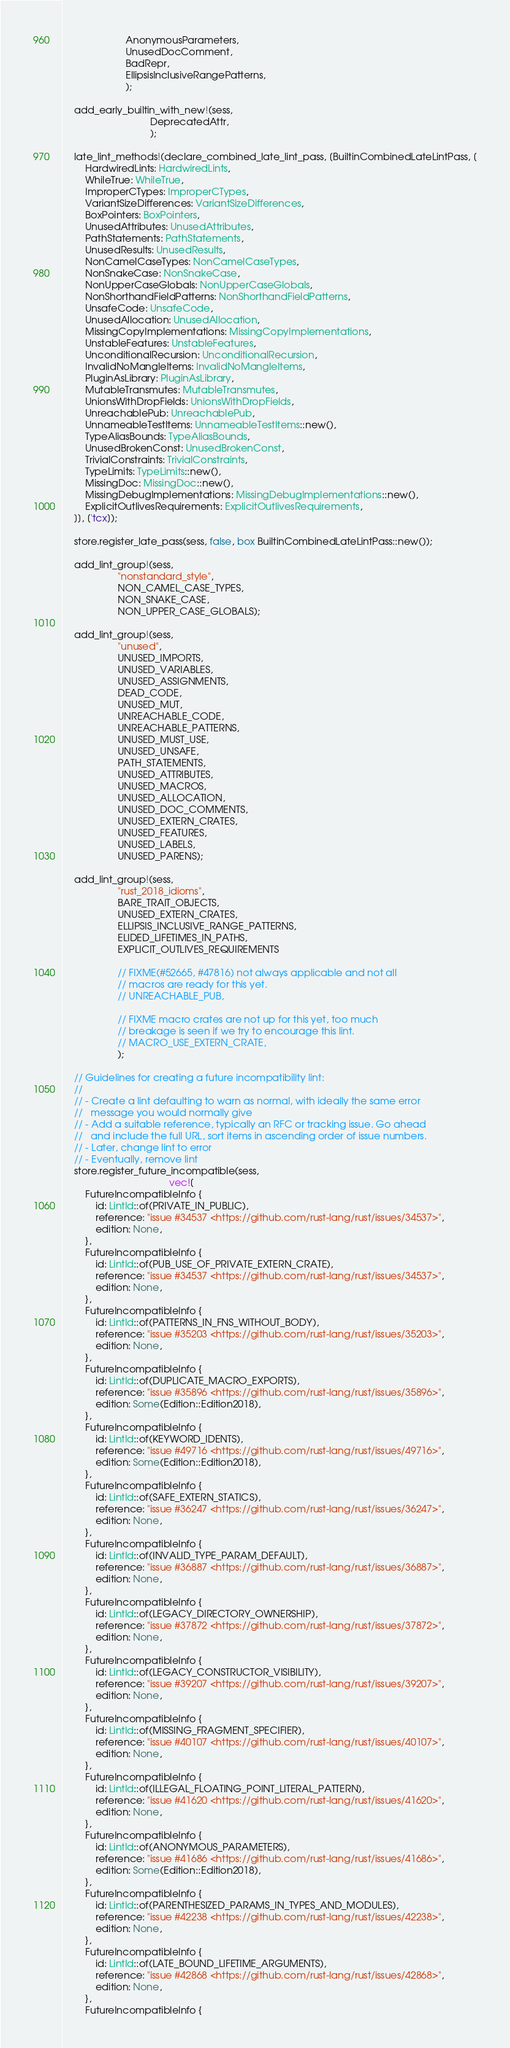Convert code to text. <code><loc_0><loc_0><loc_500><loc_500><_Rust_>                       AnonymousParameters,
                       UnusedDocComment,
                       BadRepr,
                       EllipsisInclusiveRangePatterns,
                       );

    add_early_builtin_with_new!(sess,
                                DeprecatedAttr,
                                );

    late_lint_methods!(declare_combined_late_lint_pass, [BuiltinCombinedLateLintPass, [
        HardwiredLints: HardwiredLints,
        WhileTrue: WhileTrue,
        ImproperCTypes: ImproperCTypes,
        VariantSizeDifferences: VariantSizeDifferences,
        BoxPointers: BoxPointers,
        UnusedAttributes: UnusedAttributes,
        PathStatements: PathStatements,
        UnusedResults: UnusedResults,
        NonCamelCaseTypes: NonCamelCaseTypes,
        NonSnakeCase: NonSnakeCase,
        NonUpperCaseGlobals: NonUpperCaseGlobals,
        NonShorthandFieldPatterns: NonShorthandFieldPatterns,
        UnsafeCode: UnsafeCode,
        UnusedAllocation: UnusedAllocation,
        MissingCopyImplementations: MissingCopyImplementations,
        UnstableFeatures: UnstableFeatures,
        UnconditionalRecursion: UnconditionalRecursion,
        InvalidNoMangleItems: InvalidNoMangleItems,
        PluginAsLibrary: PluginAsLibrary,
        MutableTransmutes: MutableTransmutes,
        UnionsWithDropFields: UnionsWithDropFields,
        UnreachablePub: UnreachablePub,
        UnnameableTestItems: UnnameableTestItems::new(),
        TypeAliasBounds: TypeAliasBounds,
        UnusedBrokenConst: UnusedBrokenConst,
        TrivialConstraints: TrivialConstraints,
        TypeLimits: TypeLimits::new(),
        MissingDoc: MissingDoc::new(),
        MissingDebugImplementations: MissingDebugImplementations::new(),
        ExplicitOutlivesRequirements: ExplicitOutlivesRequirements,
    ]], ['tcx]);

    store.register_late_pass(sess, false, box BuiltinCombinedLateLintPass::new());

    add_lint_group!(sess,
                    "nonstandard_style",
                    NON_CAMEL_CASE_TYPES,
                    NON_SNAKE_CASE,
                    NON_UPPER_CASE_GLOBALS);

    add_lint_group!(sess,
                    "unused",
                    UNUSED_IMPORTS,
                    UNUSED_VARIABLES,
                    UNUSED_ASSIGNMENTS,
                    DEAD_CODE,
                    UNUSED_MUT,
                    UNREACHABLE_CODE,
                    UNREACHABLE_PATTERNS,
                    UNUSED_MUST_USE,
                    UNUSED_UNSAFE,
                    PATH_STATEMENTS,
                    UNUSED_ATTRIBUTES,
                    UNUSED_MACROS,
                    UNUSED_ALLOCATION,
                    UNUSED_DOC_COMMENTS,
                    UNUSED_EXTERN_CRATES,
                    UNUSED_FEATURES,
                    UNUSED_LABELS,
                    UNUSED_PARENS);

    add_lint_group!(sess,
                    "rust_2018_idioms",
                    BARE_TRAIT_OBJECTS,
                    UNUSED_EXTERN_CRATES,
                    ELLIPSIS_INCLUSIVE_RANGE_PATTERNS,
                    ELIDED_LIFETIMES_IN_PATHS,
                    EXPLICIT_OUTLIVES_REQUIREMENTS

                    // FIXME(#52665, #47816) not always applicable and not all
                    // macros are ready for this yet.
                    // UNREACHABLE_PUB,

                    // FIXME macro crates are not up for this yet, too much
                    // breakage is seen if we try to encourage this lint.
                    // MACRO_USE_EXTERN_CRATE,
                    );

    // Guidelines for creating a future incompatibility lint:
    //
    // - Create a lint defaulting to warn as normal, with ideally the same error
    //   message you would normally give
    // - Add a suitable reference, typically an RFC or tracking issue. Go ahead
    //   and include the full URL, sort items in ascending order of issue numbers.
    // - Later, change lint to error
    // - Eventually, remove lint
    store.register_future_incompatible(sess,
                                       vec![
        FutureIncompatibleInfo {
            id: LintId::of(PRIVATE_IN_PUBLIC),
            reference: "issue #34537 <https://github.com/rust-lang/rust/issues/34537>",
            edition: None,
        },
        FutureIncompatibleInfo {
            id: LintId::of(PUB_USE_OF_PRIVATE_EXTERN_CRATE),
            reference: "issue #34537 <https://github.com/rust-lang/rust/issues/34537>",
            edition: None,
        },
        FutureIncompatibleInfo {
            id: LintId::of(PATTERNS_IN_FNS_WITHOUT_BODY),
            reference: "issue #35203 <https://github.com/rust-lang/rust/issues/35203>",
            edition: None,
        },
        FutureIncompatibleInfo {
            id: LintId::of(DUPLICATE_MACRO_EXPORTS),
            reference: "issue #35896 <https://github.com/rust-lang/rust/issues/35896>",
            edition: Some(Edition::Edition2018),
        },
        FutureIncompatibleInfo {
            id: LintId::of(KEYWORD_IDENTS),
            reference: "issue #49716 <https://github.com/rust-lang/rust/issues/49716>",
            edition: Some(Edition::Edition2018),
        },
        FutureIncompatibleInfo {
            id: LintId::of(SAFE_EXTERN_STATICS),
            reference: "issue #36247 <https://github.com/rust-lang/rust/issues/36247>",
            edition: None,
        },
        FutureIncompatibleInfo {
            id: LintId::of(INVALID_TYPE_PARAM_DEFAULT),
            reference: "issue #36887 <https://github.com/rust-lang/rust/issues/36887>",
            edition: None,
        },
        FutureIncompatibleInfo {
            id: LintId::of(LEGACY_DIRECTORY_OWNERSHIP),
            reference: "issue #37872 <https://github.com/rust-lang/rust/issues/37872>",
            edition: None,
        },
        FutureIncompatibleInfo {
            id: LintId::of(LEGACY_CONSTRUCTOR_VISIBILITY),
            reference: "issue #39207 <https://github.com/rust-lang/rust/issues/39207>",
            edition: None,
        },
        FutureIncompatibleInfo {
            id: LintId::of(MISSING_FRAGMENT_SPECIFIER),
            reference: "issue #40107 <https://github.com/rust-lang/rust/issues/40107>",
            edition: None,
        },
        FutureIncompatibleInfo {
            id: LintId::of(ILLEGAL_FLOATING_POINT_LITERAL_PATTERN),
            reference: "issue #41620 <https://github.com/rust-lang/rust/issues/41620>",
            edition: None,
        },
        FutureIncompatibleInfo {
            id: LintId::of(ANONYMOUS_PARAMETERS),
            reference: "issue #41686 <https://github.com/rust-lang/rust/issues/41686>",
            edition: Some(Edition::Edition2018),
        },
        FutureIncompatibleInfo {
            id: LintId::of(PARENTHESIZED_PARAMS_IN_TYPES_AND_MODULES),
            reference: "issue #42238 <https://github.com/rust-lang/rust/issues/42238>",
            edition: None,
        },
        FutureIncompatibleInfo {
            id: LintId::of(LATE_BOUND_LIFETIME_ARGUMENTS),
            reference: "issue #42868 <https://github.com/rust-lang/rust/issues/42868>",
            edition: None,
        },
        FutureIncompatibleInfo {</code> 